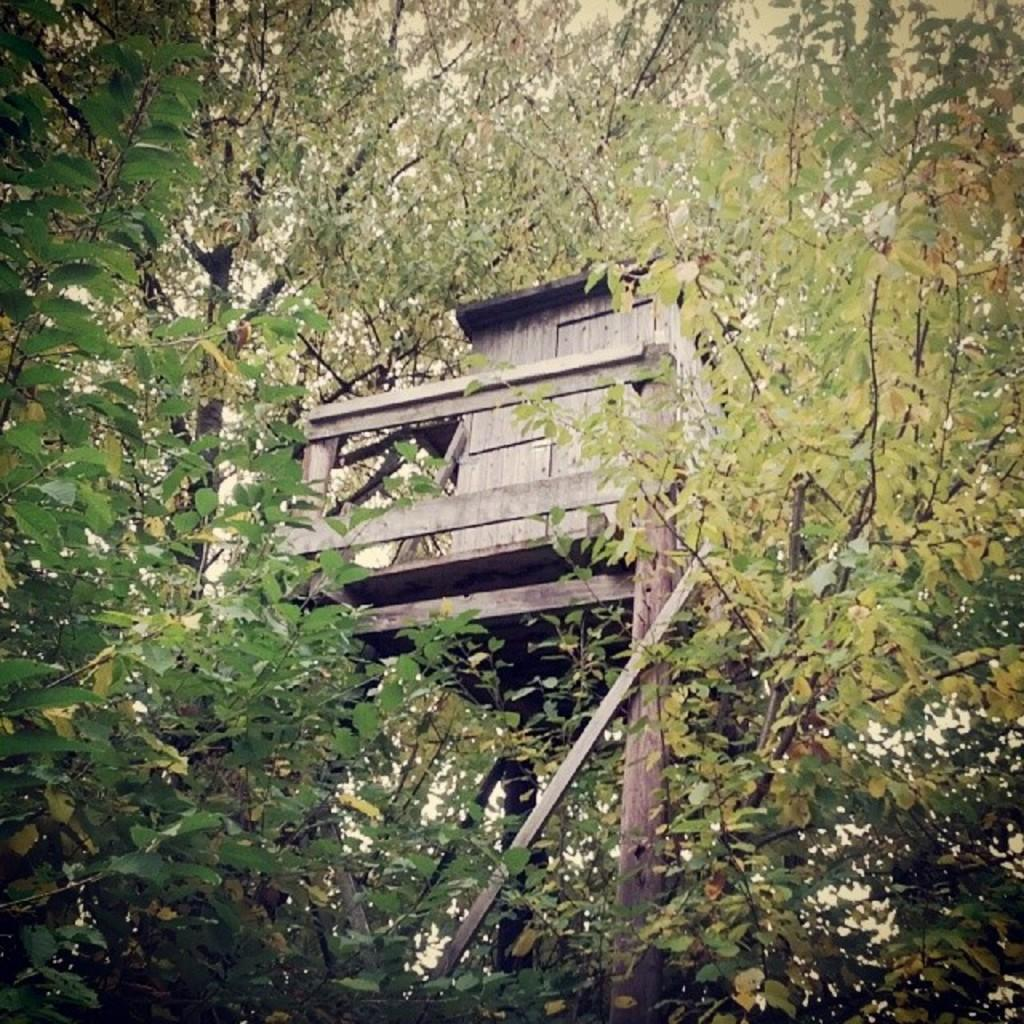What type of vegetation is present in the image? There are many trees in the image. What type of structure can be seen in the image? There is a wooden house in the image. What are the wooden house's support structures made of? The wooden house has wooden pillars. How many crooks are hiding behind the trees in the image? There are no crooks present in the image; it features trees and a wooden house. What type of reptiles can be seen slithering around the yard in the image? There are no reptiles or yard present in the image; it features trees and a wooden house. 